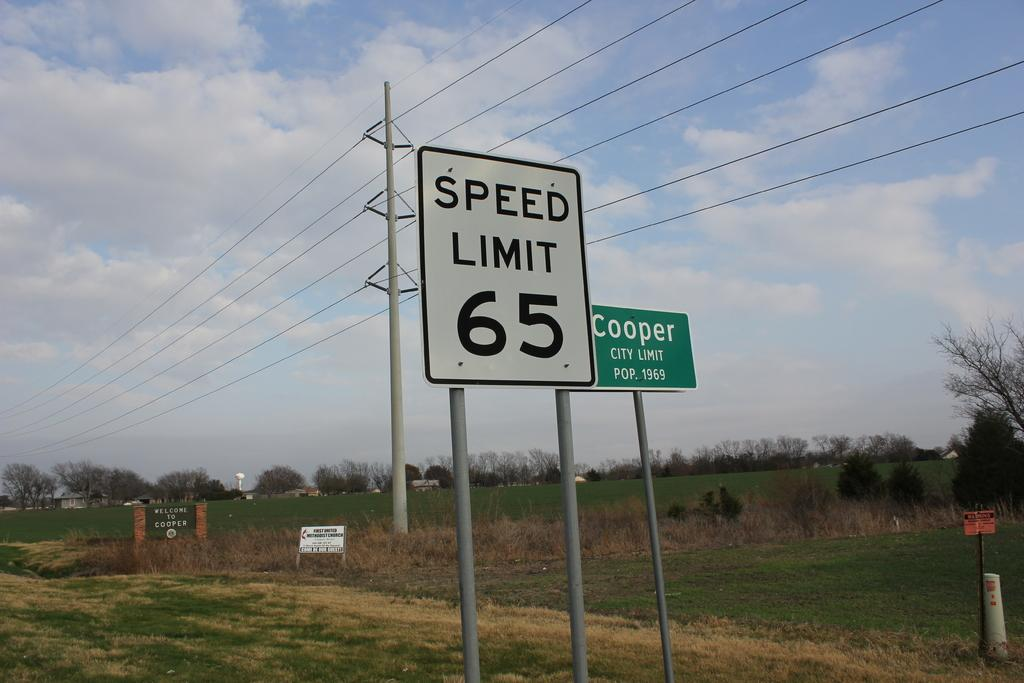<image>
Present a compact description of the photo's key features. A speed limit sign that reads 65 in the city of Cooper. 